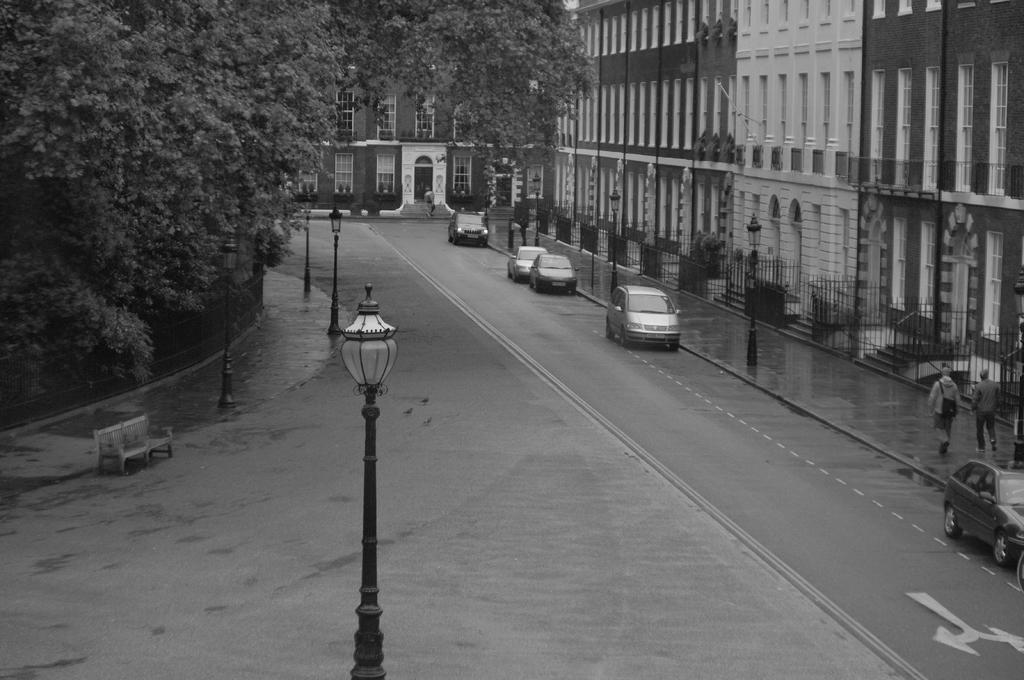Could you give a brief overview of what you see in this image? This is a black and white image. On the left side there are trees. Also there is a bench. There are light poles. There is a road. On the road there are vehicles. Near to that there is a sidewalk. Two people are walking. There are railings. Also there are buildings with windows and arches. 